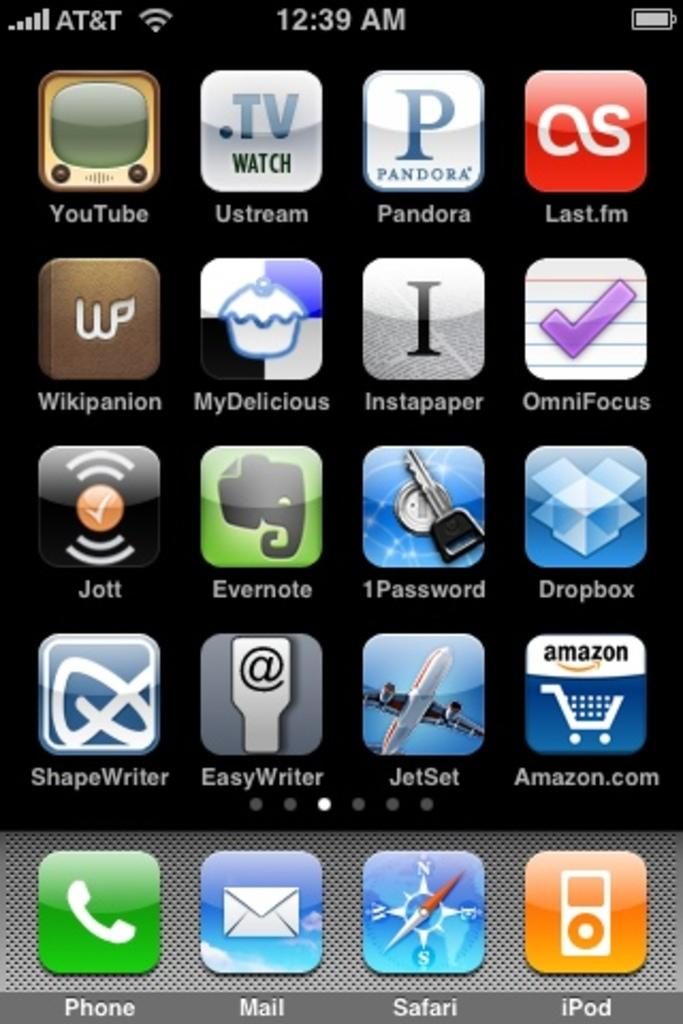<image>
Describe the image concisely. an iphone screen that says at&t at the top left of it 